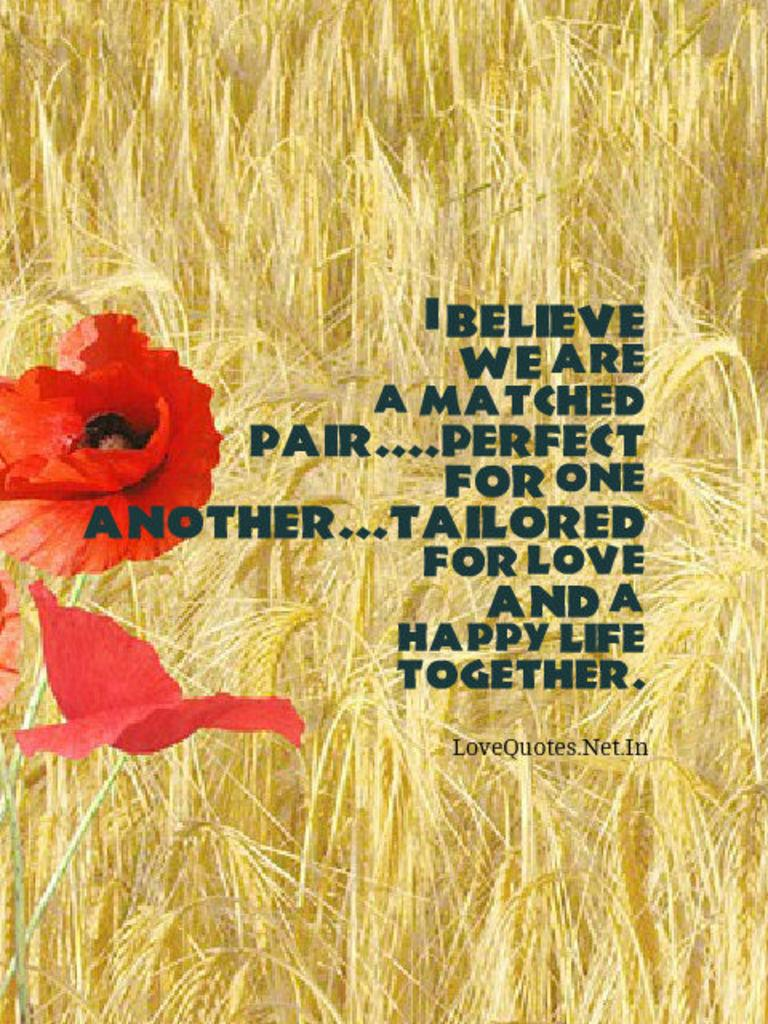What is featured in the image? There is a poster in the image. What can be seen in the background of the poster? The poster has plants in the background. Where are the flowers located on the poster? There are two flowers on the left side of the poster. What is present in the middle of the poster? There is text in the middle of the poster. What type of spark can be seen coming from the plantation in the image? There is no plantation or spark present in the image; it features a poster with plants in the background and flowers on the left side. 